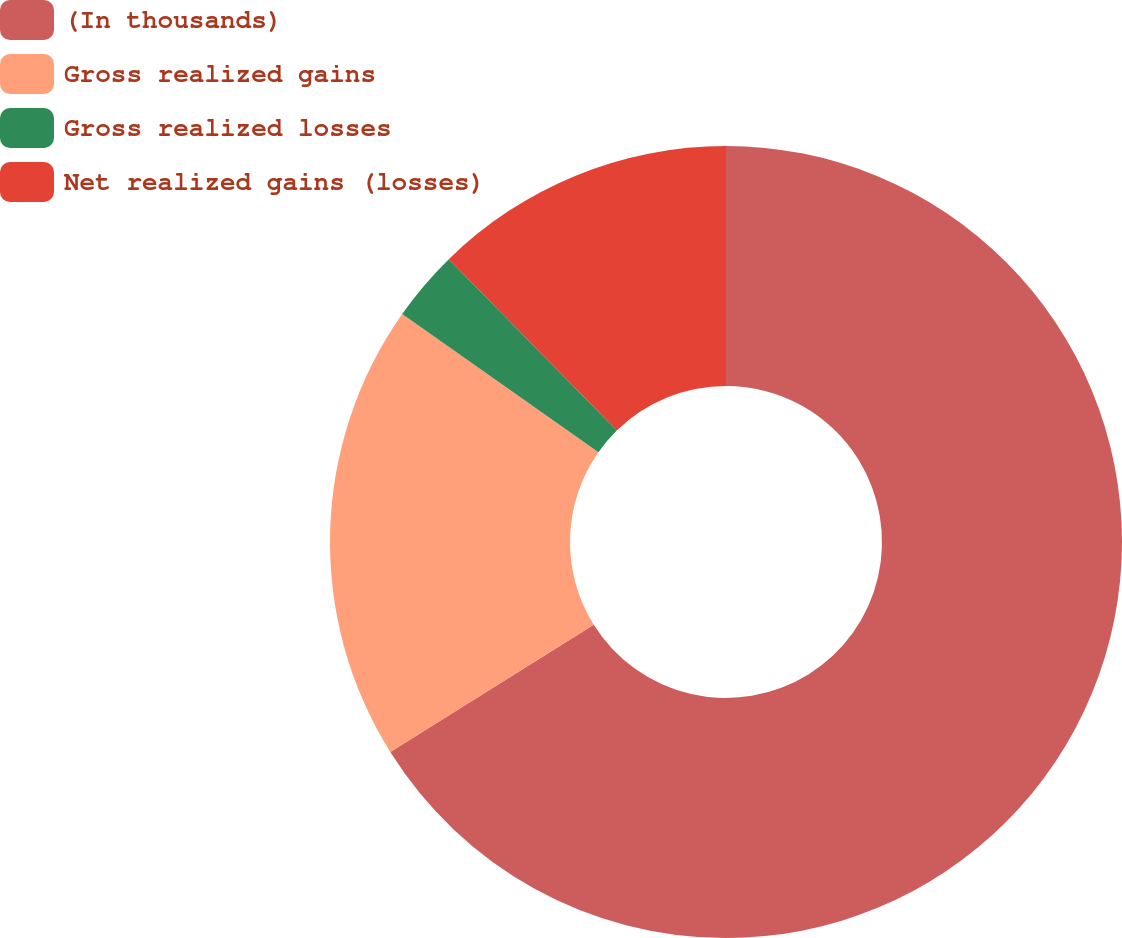Convert chart to OTSL. <chart><loc_0><loc_0><loc_500><loc_500><pie_chart><fcel>(In thousands)<fcel>Gross realized gains<fcel>Gross realized losses<fcel>Net realized gains (losses)<nl><fcel>66.1%<fcel>18.66%<fcel>2.9%<fcel>12.34%<nl></chart> 